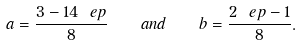Convert formula to latex. <formula><loc_0><loc_0><loc_500><loc_500>a = \frac { 3 - 1 4 \ e p } { 8 } \quad a n d \quad b = \frac { 2 \ e p - 1 } { 8 } .</formula> 